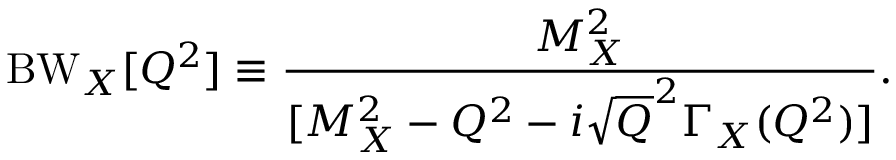<formula> <loc_0><loc_0><loc_500><loc_500>B W _ { X } [ Q ^ { 2 } ] \equiv \frac { M _ { X } ^ { 2 } } { [ M _ { X } ^ { 2 } - Q ^ { 2 } - i \sqrt { Q } ^ { 2 } \Gamma _ { X } ( Q ^ { 2 } ) ] } .</formula> 